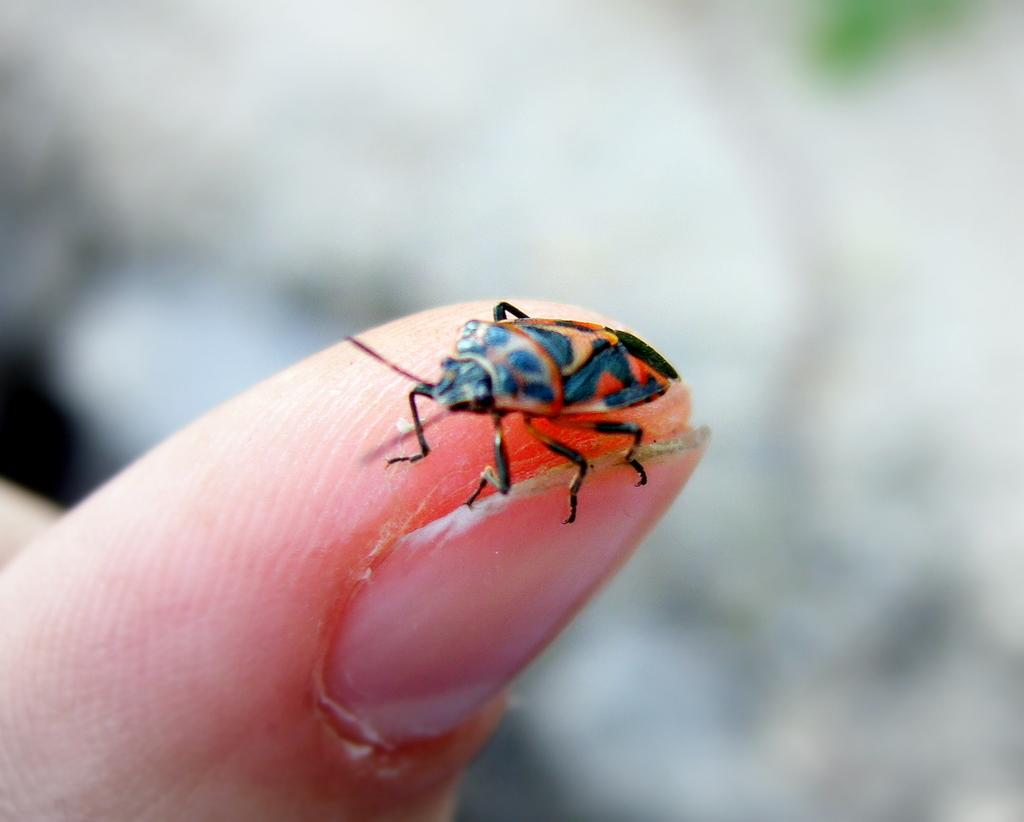What is present on the person's finger in the image? There is an insect on the person's finger in the image. Can you describe the insect in the image? Unfortunately, the provided facts do not include a description of the insect. What can be observed about the background of the image? The background of the image is blurry. How many birds are sitting on the kettle in the image? There are no birds or kettles present in the image. 